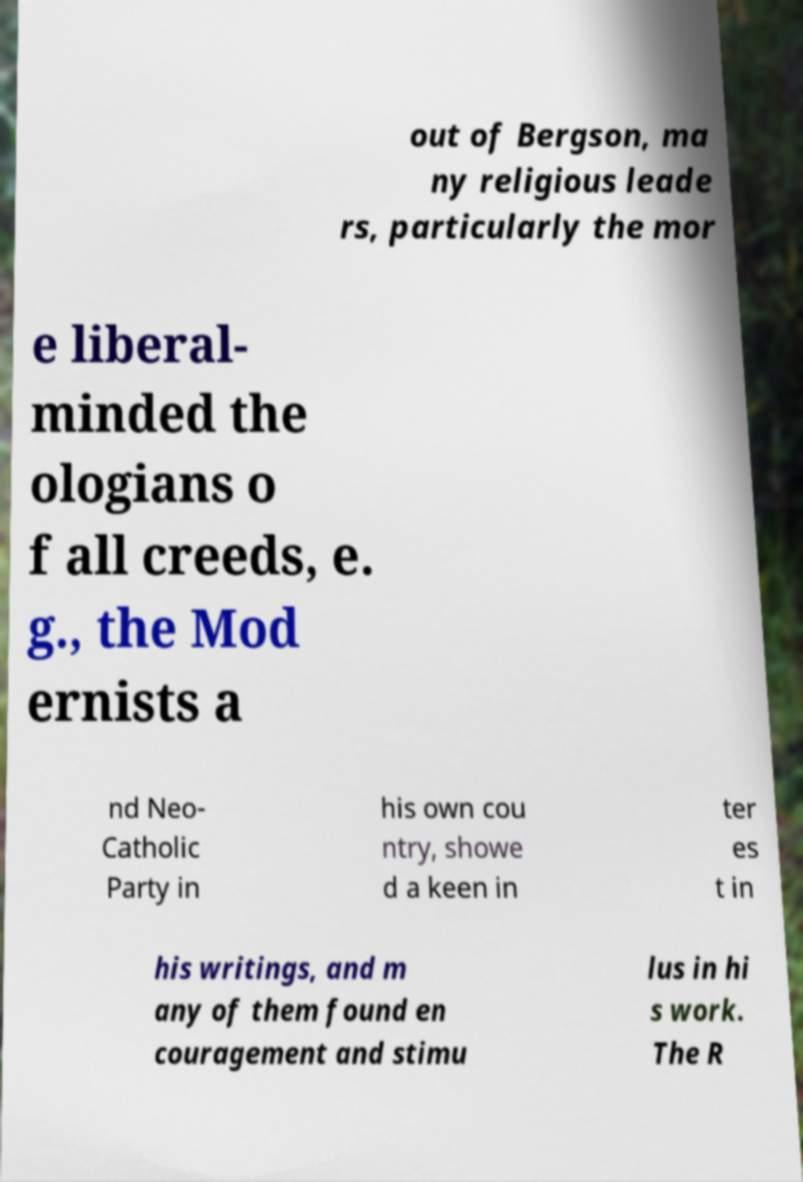There's text embedded in this image that I need extracted. Can you transcribe it verbatim? out of Bergson, ma ny religious leade rs, particularly the mor e liberal- minded the ologians o f all creeds, e. g., the Mod ernists a nd Neo- Catholic Party in his own cou ntry, showe d a keen in ter es t in his writings, and m any of them found en couragement and stimu lus in hi s work. The R 